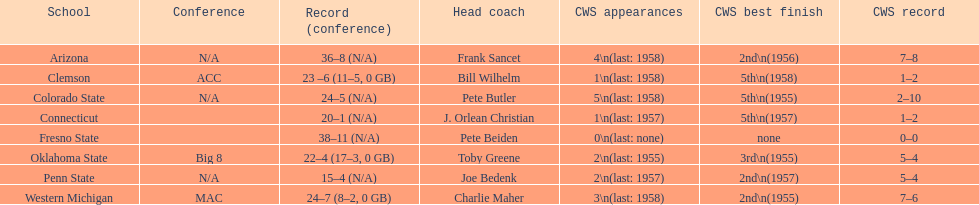What is the count of clemson's appearances in the college world series? 1\n(last: 1958). What is the count of western michigan's appearances in the college world series? 3\n(last: 1958). Between these two schools, which one has more appearances in the college world series? Western Michigan. 